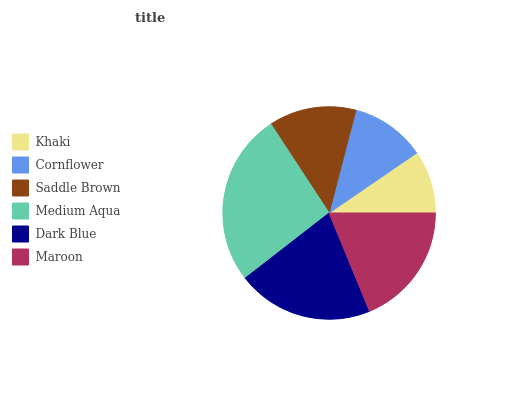Is Khaki the minimum?
Answer yes or no. Yes. Is Medium Aqua the maximum?
Answer yes or no. Yes. Is Cornflower the minimum?
Answer yes or no. No. Is Cornflower the maximum?
Answer yes or no. No. Is Cornflower greater than Khaki?
Answer yes or no. Yes. Is Khaki less than Cornflower?
Answer yes or no. Yes. Is Khaki greater than Cornflower?
Answer yes or no. No. Is Cornflower less than Khaki?
Answer yes or no. No. Is Maroon the high median?
Answer yes or no. Yes. Is Saddle Brown the low median?
Answer yes or no. Yes. Is Dark Blue the high median?
Answer yes or no. No. Is Cornflower the low median?
Answer yes or no. No. 